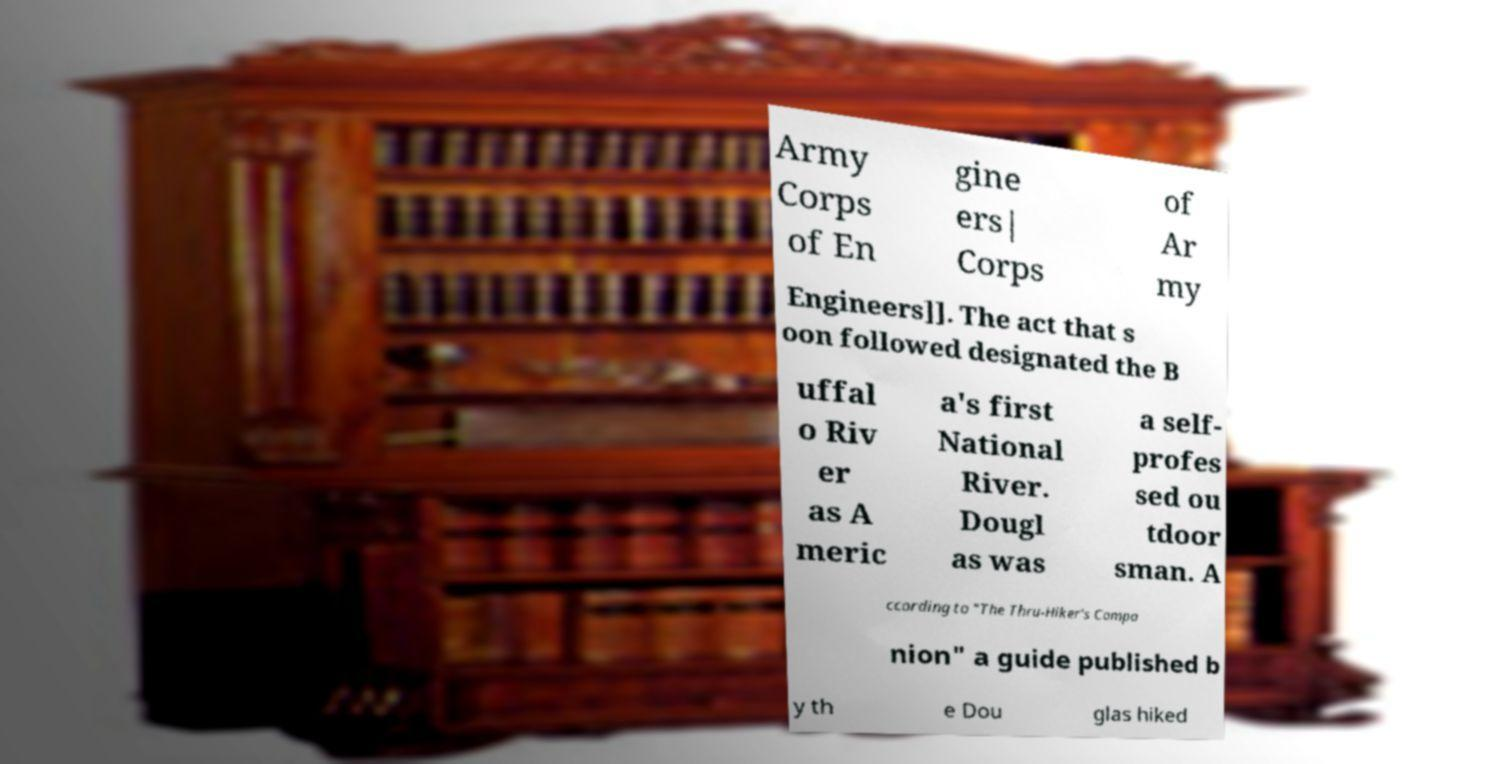What messages or text are displayed in this image? I need them in a readable, typed format. Army Corps of En gine ers| Corps of Ar my Engineers]]. The act that s oon followed designated the B uffal o Riv er as A meric a's first National River. Dougl as was a self- profes sed ou tdoor sman. A ccording to "The Thru-Hiker's Compa nion" a guide published b y th e Dou glas hiked 